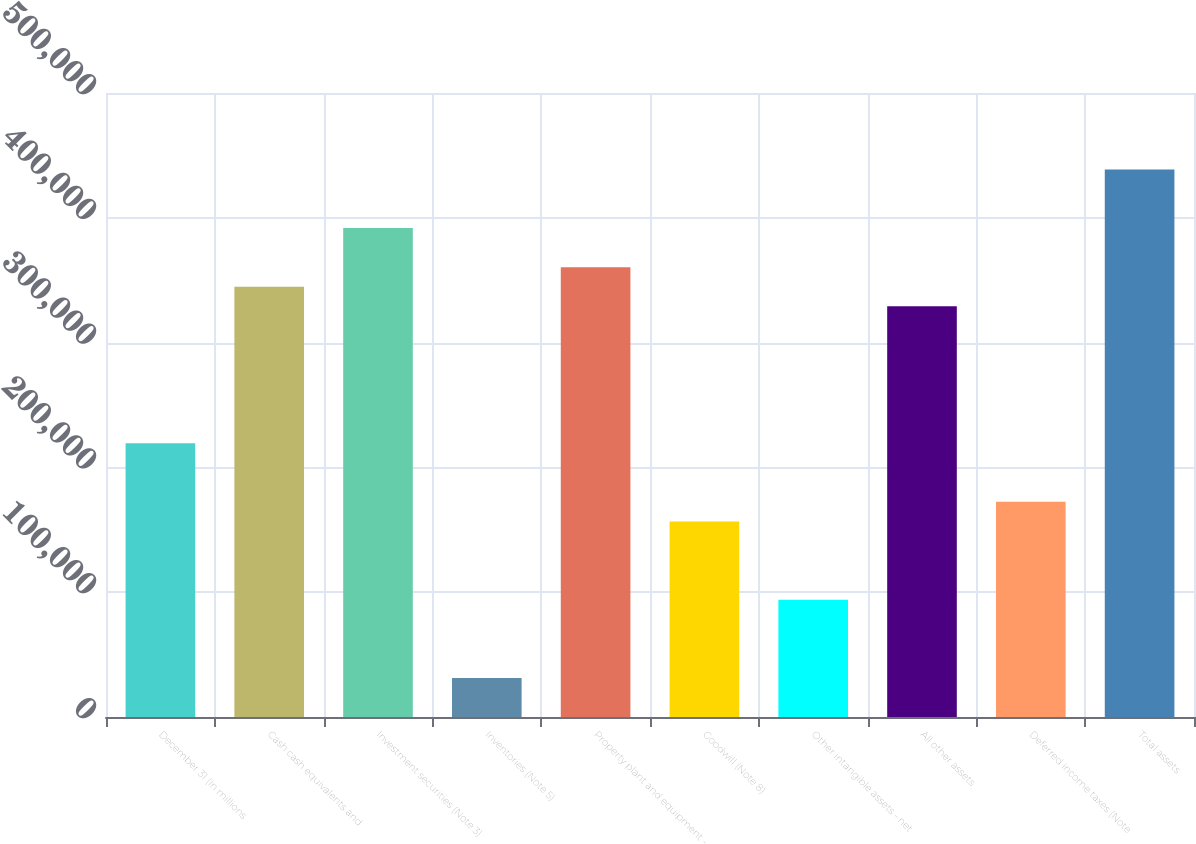<chart> <loc_0><loc_0><loc_500><loc_500><bar_chart><fcel>December 31 (In millions<fcel>Cash cash equivalents and<fcel>Investment securities (Note 3)<fcel>Inventories (Note 5)<fcel>Property plant and equipment -<fcel>Goodwill (Note 8)<fcel>Other intangible assets - net<fcel>All other assets<fcel>Deferred income taxes (Note<fcel>Total assets<nl><fcel>219400<fcel>344768<fcel>391781<fcel>31348<fcel>360439<fcel>156716<fcel>94032<fcel>329097<fcel>172387<fcel>438794<nl></chart> 